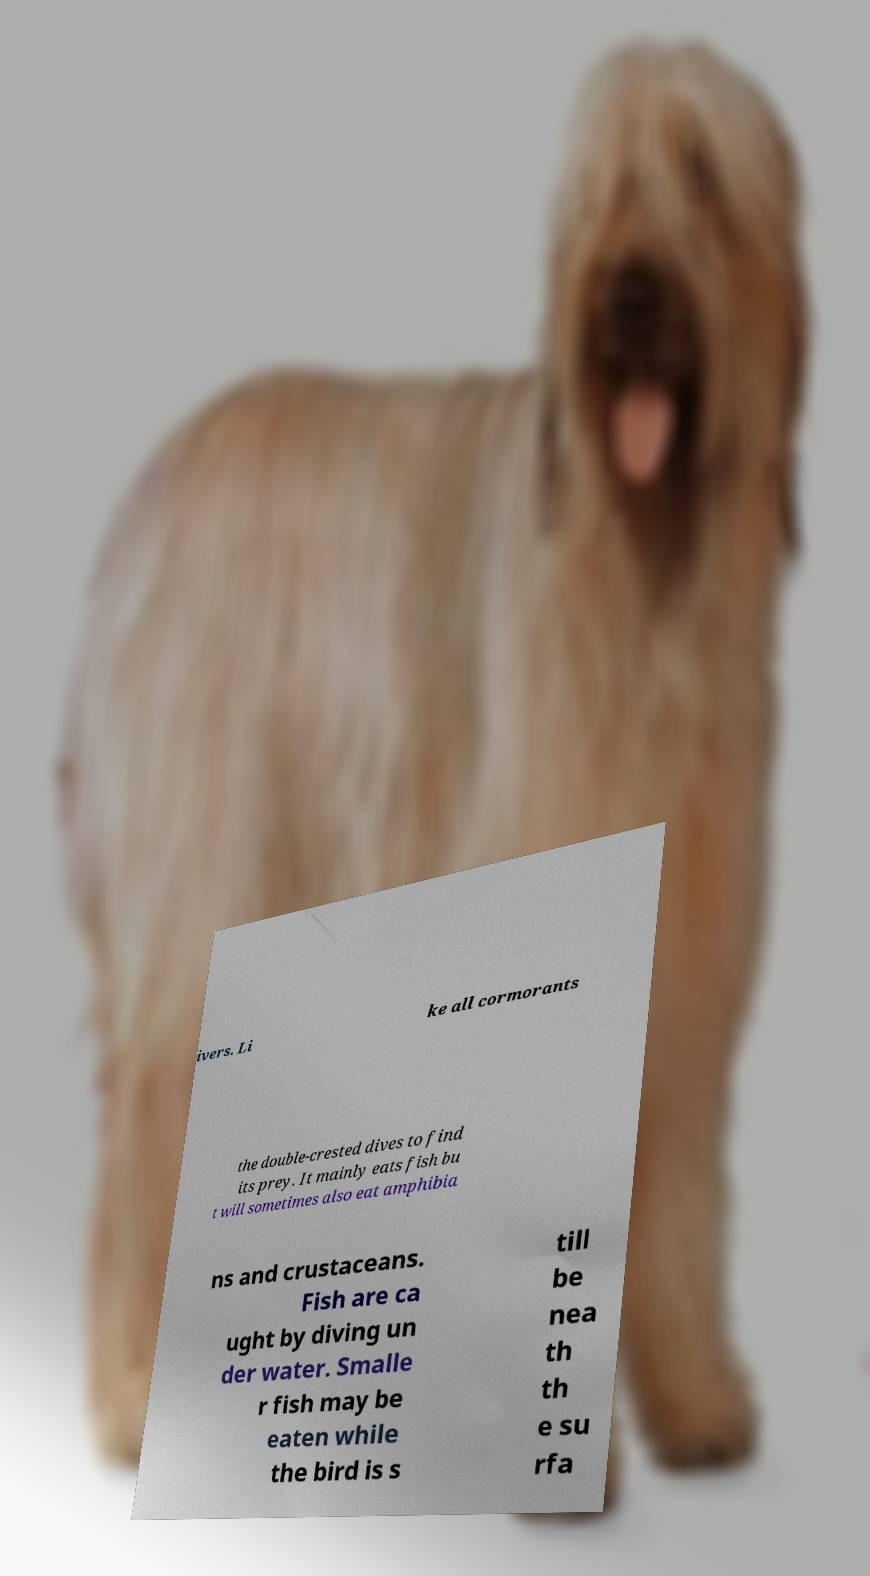What messages or text are displayed in this image? I need them in a readable, typed format. ivers. Li ke all cormorants the double-crested dives to find its prey. It mainly eats fish bu t will sometimes also eat amphibia ns and crustaceans. Fish are ca ught by diving un der water. Smalle r fish may be eaten while the bird is s till be nea th th e su rfa 